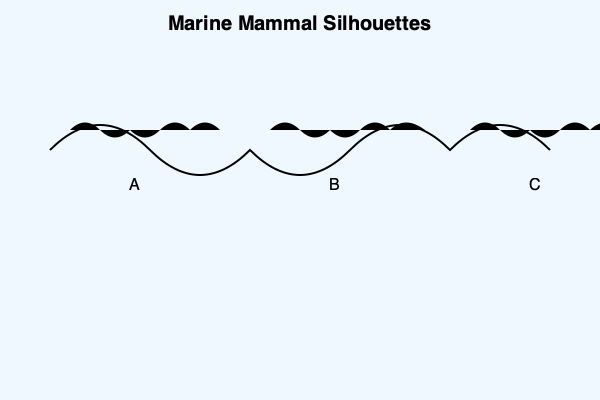Based on the silhouettes shown in the image, which of these marine mammals (A, B, or C) is most likely to be a blue whale? To identify the blue whale from the given silhouettes, we need to consider the following characteristics:

1. Size and proportions: Blue whales are the largest animals on Earth, with a long, streamlined body.
2. Head shape: Blue whales have a relatively small, flat head compared to their body size.
3. Dorsal fin: Blue whales have a small dorsal fin located far back on their body.
4. Fluke (tail) shape: Blue whales have wide, triangular flukes.

Analyzing the silhouettes:

A: This silhouette shows a smaller cetacean with a prominent dorsal fin in the middle of its back and a curved, falcate dorsal fin. This is likely a dolphin or a small whale species.

B: This silhouette displays a large, streamlined body with a small dorsal fin positioned far back on the body. The head appears relatively small and flat compared to the body size. These features are consistent with a blue whale.

C: This silhouette shows a large cetacean with a pronounced hump on its back instead of a dorsal fin. The head is also relatively large compared to the body. These characteristics are more consistent with a humpback whale.

Based on these observations, the silhouette most likely to represent a blue whale is B.
Answer: B 